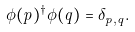<formula> <loc_0><loc_0><loc_500><loc_500>\phi ( \vec { p } ) ^ { \dagger } \phi ( \vec { q } ) = \delta _ { \vec { p } , \vec { q } } .</formula> 